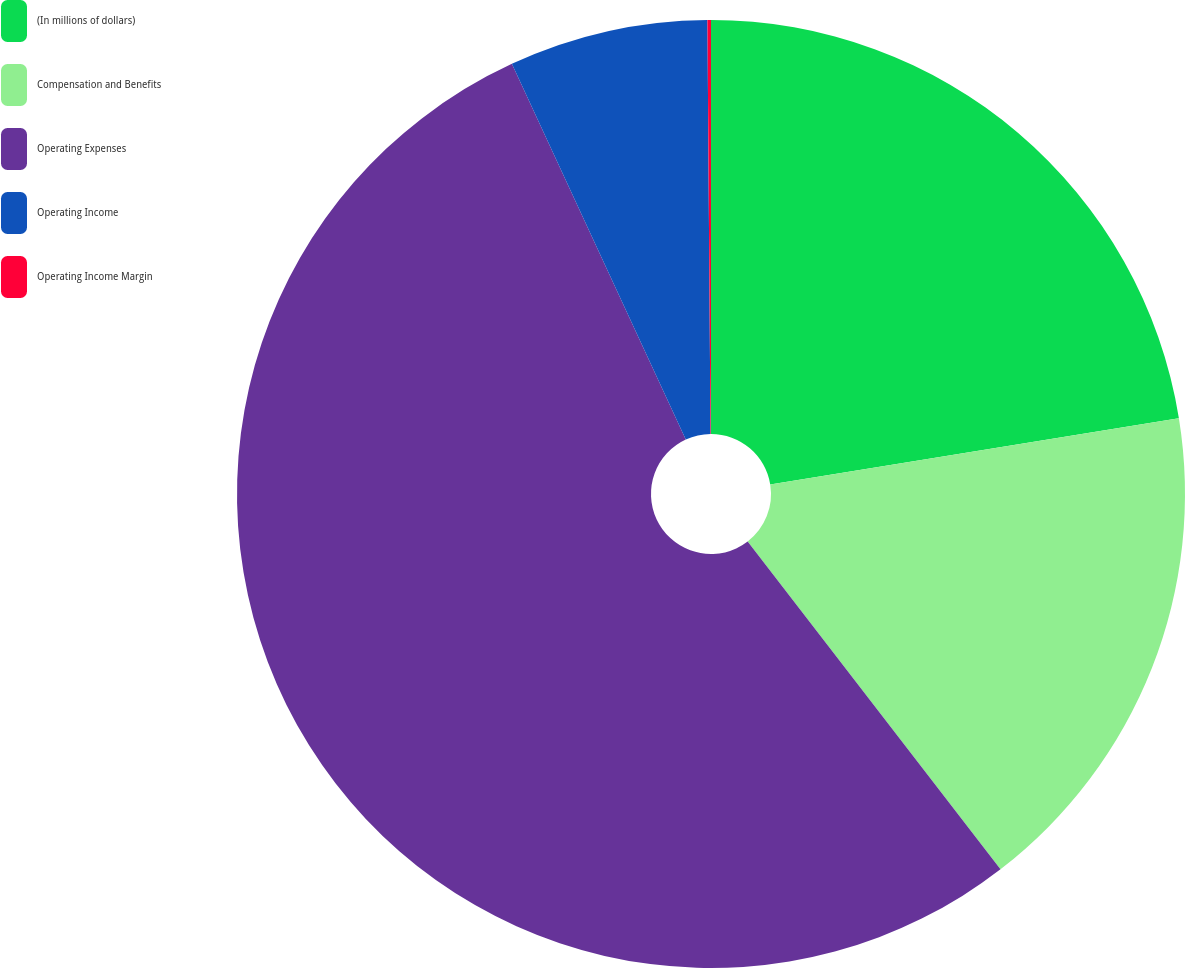<chart> <loc_0><loc_0><loc_500><loc_500><pie_chart><fcel>(In millions of dollars)<fcel>Compensation and Benefits<fcel>Operating Expenses<fcel>Operating Income<fcel>Operating Income Margin<nl><fcel>22.44%<fcel>17.1%<fcel>53.55%<fcel>6.78%<fcel>0.12%<nl></chart> 